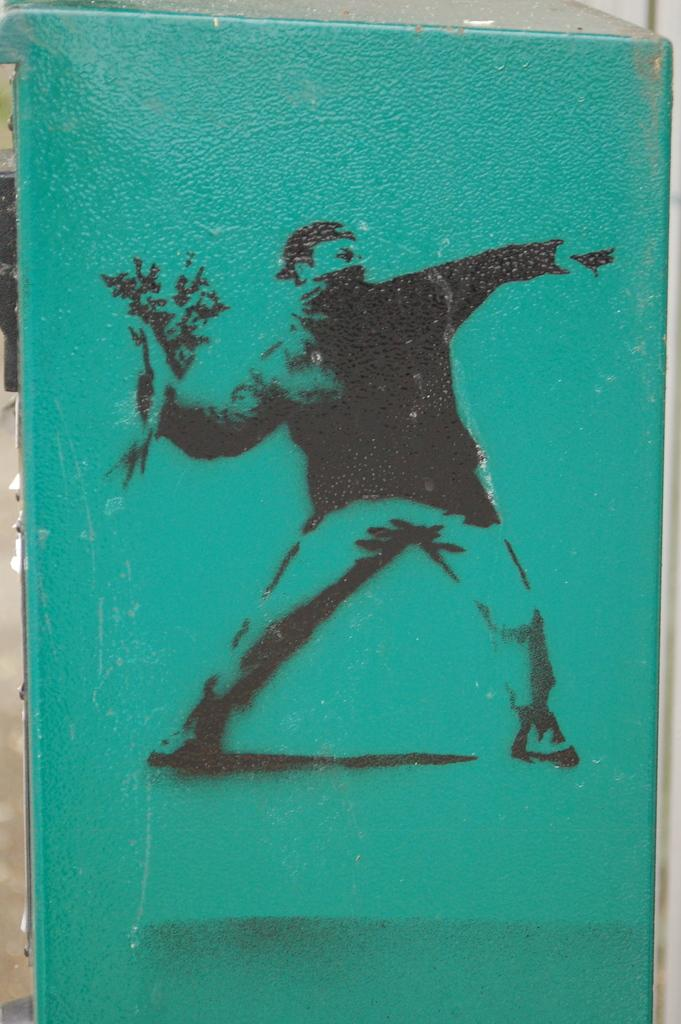What type of artwork is shown in the image? The image is a painting. Who or what is the main subject of the painting? The painting depicts a person. What is the person holding in the painting? The person is holding a flower bouquet. What is the person's posture in the painting? The person is standing. What color is the background of the painting? The background of the painting is green in color. Can you tell me how many clams are present in the painting? There are no clams present in the painting; it features a person holding a flower bouquet against a green background. 